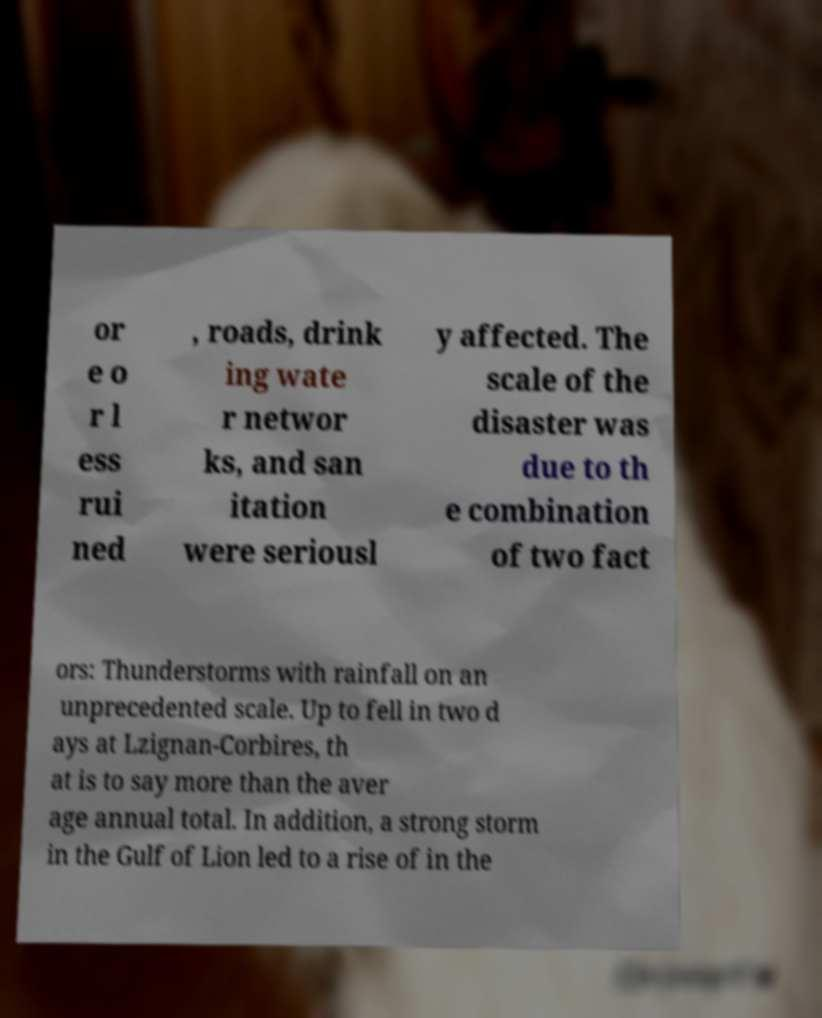Could you assist in decoding the text presented in this image and type it out clearly? or e o r l ess rui ned , roads, drink ing wate r networ ks, and san itation were seriousl y affected. The scale of the disaster was due to th e combination of two fact ors: Thunderstorms with rainfall on an unprecedented scale. Up to fell in two d ays at Lzignan-Corbires, th at is to say more than the aver age annual total. In addition, a strong storm in the Gulf of Lion led to a rise of in the 